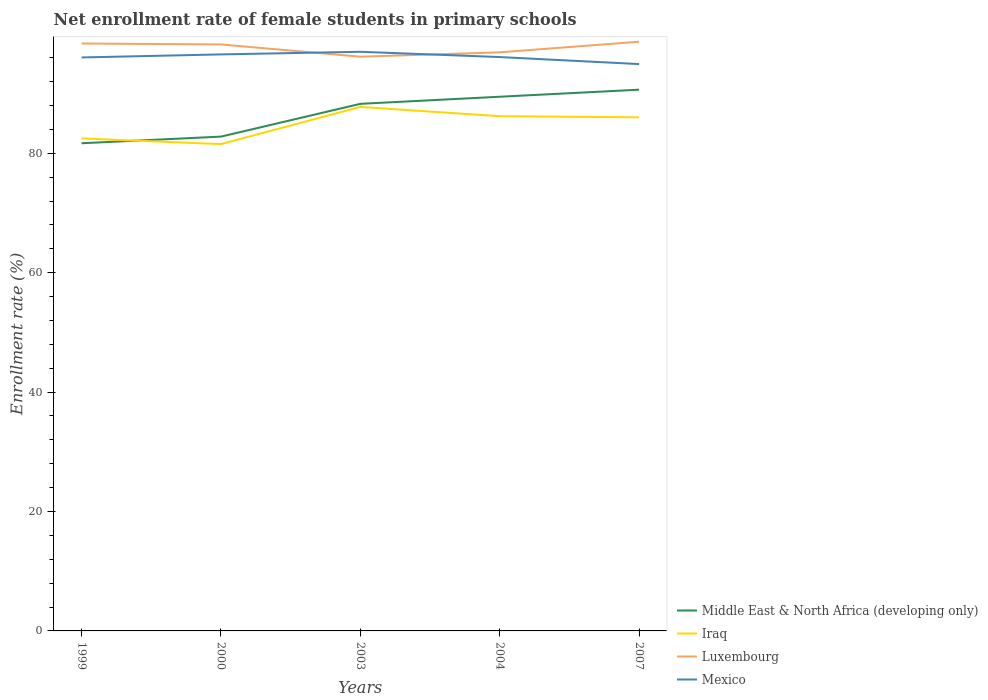How many different coloured lines are there?
Offer a terse response. 4. Does the line corresponding to Middle East & North Africa (developing only) intersect with the line corresponding to Mexico?
Give a very brief answer. No. Across all years, what is the maximum net enrollment rate of female students in primary schools in Luxembourg?
Provide a succinct answer. 96.18. What is the total net enrollment rate of female students in primary schools in Iraq in the graph?
Give a very brief answer. 0.95. What is the difference between the highest and the second highest net enrollment rate of female students in primary schools in Middle East & North Africa (developing only)?
Your answer should be very brief. 8.97. What is the difference between the highest and the lowest net enrollment rate of female students in primary schools in Middle East & North Africa (developing only)?
Ensure brevity in your answer.  3. How many lines are there?
Offer a terse response. 4. Are the values on the major ticks of Y-axis written in scientific E-notation?
Your answer should be compact. No. Does the graph contain grids?
Your answer should be very brief. No. Where does the legend appear in the graph?
Your response must be concise. Bottom right. How are the legend labels stacked?
Your answer should be compact. Vertical. What is the title of the graph?
Make the answer very short. Net enrollment rate of female students in primary schools. Does "Bermuda" appear as one of the legend labels in the graph?
Provide a succinct answer. No. What is the label or title of the X-axis?
Your answer should be compact. Years. What is the label or title of the Y-axis?
Your answer should be compact. Enrollment rate (%). What is the Enrollment rate (%) in Middle East & North Africa (developing only) in 1999?
Provide a succinct answer. 81.68. What is the Enrollment rate (%) in Iraq in 1999?
Offer a very short reply. 82.49. What is the Enrollment rate (%) of Luxembourg in 1999?
Your response must be concise. 98.39. What is the Enrollment rate (%) in Mexico in 1999?
Offer a very short reply. 96.05. What is the Enrollment rate (%) of Middle East & North Africa (developing only) in 2000?
Offer a terse response. 82.79. What is the Enrollment rate (%) in Iraq in 2000?
Provide a short and direct response. 81.54. What is the Enrollment rate (%) in Luxembourg in 2000?
Your answer should be very brief. 98.23. What is the Enrollment rate (%) of Mexico in 2000?
Provide a succinct answer. 96.56. What is the Enrollment rate (%) of Middle East & North Africa (developing only) in 2003?
Offer a terse response. 88.28. What is the Enrollment rate (%) in Iraq in 2003?
Make the answer very short. 87.76. What is the Enrollment rate (%) in Luxembourg in 2003?
Your answer should be very brief. 96.18. What is the Enrollment rate (%) in Mexico in 2003?
Offer a very short reply. 97. What is the Enrollment rate (%) in Middle East & North Africa (developing only) in 2004?
Your answer should be compact. 89.47. What is the Enrollment rate (%) in Iraq in 2004?
Give a very brief answer. 86.21. What is the Enrollment rate (%) of Luxembourg in 2004?
Ensure brevity in your answer.  96.9. What is the Enrollment rate (%) of Mexico in 2004?
Keep it short and to the point. 96.11. What is the Enrollment rate (%) in Middle East & North Africa (developing only) in 2007?
Your answer should be very brief. 90.65. What is the Enrollment rate (%) of Iraq in 2007?
Provide a succinct answer. 86.02. What is the Enrollment rate (%) in Luxembourg in 2007?
Your answer should be very brief. 98.69. What is the Enrollment rate (%) in Mexico in 2007?
Provide a short and direct response. 94.94. Across all years, what is the maximum Enrollment rate (%) of Middle East & North Africa (developing only)?
Provide a short and direct response. 90.65. Across all years, what is the maximum Enrollment rate (%) in Iraq?
Provide a succinct answer. 87.76. Across all years, what is the maximum Enrollment rate (%) in Luxembourg?
Offer a terse response. 98.69. Across all years, what is the maximum Enrollment rate (%) in Mexico?
Provide a short and direct response. 97. Across all years, what is the minimum Enrollment rate (%) of Middle East & North Africa (developing only)?
Your response must be concise. 81.68. Across all years, what is the minimum Enrollment rate (%) in Iraq?
Your answer should be very brief. 81.54. Across all years, what is the minimum Enrollment rate (%) of Luxembourg?
Provide a short and direct response. 96.18. Across all years, what is the minimum Enrollment rate (%) in Mexico?
Your answer should be very brief. 94.94. What is the total Enrollment rate (%) of Middle East & North Africa (developing only) in the graph?
Provide a short and direct response. 432.87. What is the total Enrollment rate (%) of Iraq in the graph?
Ensure brevity in your answer.  424.02. What is the total Enrollment rate (%) in Luxembourg in the graph?
Your response must be concise. 488.38. What is the total Enrollment rate (%) of Mexico in the graph?
Your response must be concise. 480.66. What is the difference between the Enrollment rate (%) of Middle East & North Africa (developing only) in 1999 and that in 2000?
Your answer should be compact. -1.11. What is the difference between the Enrollment rate (%) of Iraq in 1999 and that in 2000?
Give a very brief answer. 0.95. What is the difference between the Enrollment rate (%) in Luxembourg in 1999 and that in 2000?
Make the answer very short. 0.16. What is the difference between the Enrollment rate (%) in Mexico in 1999 and that in 2000?
Offer a very short reply. -0.51. What is the difference between the Enrollment rate (%) in Middle East & North Africa (developing only) in 1999 and that in 2003?
Give a very brief answer. -6.6. What is the difference between the Enrollment rate (%) in Iraq in 1999 and that in 2003?
Offer a very short reply. -5.28. What is the difference between the Enrollment rate (%) in Luxembourg in 1999 and that in 2003?
Offer a very short reply. 2.21. What is the difference between the Enrollment rate (%) in Mexico in 1999 and that in 2003?
Offer a terse response. -0.95. What is the difference between the Enrollment rate (%) in Middle East & North Africa (developing only) in 1999 and that in 2004?
Offer a very short reply. -7.79. What is the difference between the Enrollment rate (%) in Iraq in 1999 and that in 2004?
Ensure brevity in your answer.  -3.72. What is the difference between the Enrollment rate (%) of Luxembourg in 1999 and that in 2004?
Make the answer very short. 1.48. What is the difference between the Enrollment rate (%) of Mexico in 1999 and that in 2004?
Your response must be concise. -0.07. What is the difference between the Enrollment rate (%) in Middle East & North Africa (developing only) in 1999 and that in 2007?
Ensure brevity in your answer.  -8.97. What is the difference between the Enrollment rate (%) of Iraq in 1999 and that in 2007?
Offer a terse response. -3.53. What is the difference between the Enrollment rate (%) of Luxembourg in 1999 and that in 2007?
Give a very brief answer. -0.3. What is the difference between the Enrollment rate (%) of Mexico in 1999 and that in 2007?
Provide a succinct answer. 1.11. What is the difference between the Enrollment rate (%) in Middle East & North Africa (developing only) in 2000 and that in 2003?
Make the answer very short. -5.49. What is the difference between the Enrollment rate (%) in Iraq in 2000 and that in 2003?
Make the answer very short. -6.23. What is the difference between the Enrollment rate (%) in Luxembourg in 2000 and that in 2003?
Give a very brief answer. 2.05. What is the difference between the Enrollment rate (%) of Mexico in 2000 and that in 2003?
Your answer should be very brief. -0.44. What is the difference between the Enrollment rate (%) in Middle East & North Africa (developing only) in 2000 and that in 2004?
Offer a very short reply. -6.68. What is the difference between the Enrollment rate (%) in Iraq in 2000 and that in 2004?
Make the answer very short. -4.67. What is the difference between the Enrollment rate (%) of Luxembourg in 2000 and that in 2004?
Offer a terse response. 1.32. What is the difference between the Enrollment rate (%) in Mexico in 2000 and that in 2004?
Your response must be concise. 0.45. What is the difference between the Enrollment rate (%) in Middle East & North Africa (developing only) in 2000 and that in 2007?
Your answer should be very brief. -7.86. What is the difference between the Enrollment rate (%) of Iraq in 2000 and that in 2007?
Offer a very short reply. -4.48. What is the difference between the Enrollment rate (%) of Luxembourg in 2000 and that in 2007?
Provide a succinct answer. -0.46. What is the difference between the Enrollment rate (%) in Mexico in 2000 and that in 2007?
Your response must be concise. 1.62. What is the difference between the Enrollment rate (%) of Middle East & North Africa (developing only) in 2003 and that in 2004?
Offer a terse response. -1.19. What is the difference between the Enrollment rate (%) in Iraq in 2003 and that in 2004?
Your response must be concise. 1.55. What is the difference between the Enrollment rate (%) of Luxembourg in 2003 and that in 2004?
Keep it short and to the point. -0.73. What is the difference between the Enrollment rate (%) of Mexico in 2003 and that in 2004?
Your response must be concise. 0.88. What is the difference between the Enrollment rate (%) of Middle East & North Africa (developing only) in 2003 and that in 2007?
Provide a succinct answer. -2.37. What is the difference between the Enrollment rate (%) of Iraq in 2003 and that in 2007?
Keep it short and to the point. 1.74. What is the difference between the Enrollment rate (%) of Luxembourg in 2003 and that in 2007?
Make the answer very short. -2.51. What is the difference between the Enrollment rate (%) in Mexico in 2003 and that in 2007?
Make the answer very short. 2.06. What is the difference between the Enrollment rate (%) in Middle East & North Africa (developing only) in 2004 and that in 2007?
Make the answer very short. -1.18. What is the difference between the Enrollment rate (%) of Iraq in 2004 and that in 2007?
Offer a terse response. 0.19. What is the difference between the Enrollment rate (%) of Luxembourg in 2004 and that in 2007?
Your response must be concise. -1.78. What is the difference between the Enrollment rate (%) of Mexico in 2004 and that in 2007?
Provide a short and direct response. 1.18. What is the difference between the Enrollment rate (%) of Middle East & North Africa (developing only) in 1999 and the Enrollment rate (%) of Iraq in 2000?
Give a very brief answer. 0.14. What is the difference between the Enrollment rate (%) in Middle East & North Africa (developing only) in 1999 and the Enrollment rate (%) in Luxembourg in 2000?
Ensure brevity in your answer.  -16.55. What is the difference between the Enrollment rate (%) in Middle East & North Africa (developing only) in 1999 and the Enrollment rate (%) in Mexico in 2000?
Offer a very short reply. -14.88. What is the difference between the Enrollment rate (%) in Iraq in 1999 and the Enrollment rate (%) in Luxembourg in 2000?
Offer a terse response. -15.74. What is the difference between the Enrollment rate (%) in Iraq in 1999 and the Enrollment rate (%) in Mexico in 2000?
Make the answer very short. -14.07. What is the difference between the Enrollment rate (%) in Luxembourg in 1999 and the Enrollment rate (%) in Mexico in 2000?
Keep it short and to the point. 1.83. What is the difference between the Enrollment rate (%) in Middle East & North Africa (developing only) in 1999 and the Enrollment rate (%) in Iraq in 2003?
Provide a short and direct response. -6.09. What is the difference between the Enrollment rate (%) of Middle East & North Africa (developing only) in 1999 and the Enrollment rate (%) of Luxembourg in 2003?
Give a very brief answer. -14.5. What is the difference between the Enrollment rate (%) in Middle East & North Africa (developing only) in 1999 and the Enrollment rate (%) in Mexico in 2003?
Offer a terse response. -15.32. What is the difference between the Enrollment rate (%) in Iraq in 1999 and the Enrollment rate (%) in Luxembourg in 2003?
Provide a short and direct response. -13.69. What is the difference between the Enrollment rate (%) in Iraq in 1999 and the Enrollment rate (%) in Mexico in 2003?
Your response must be concise. -14.51. What is the difference between the Enrollment rate (%) of Luxembourg in 1999 and the Enrollment rate (%) of Mexico in 2003?
Your response must be concise. 1.39. What is the difference between the Enrollment rate (%) in Middle East & North Africa (developing only) in 1999 and the Enrollment rate (%) in Iraq in 2004?
Ensure brevity in your answer.  -4.53. What is the difference between the Enrollment rate (%) in Middle East & North Africa (developing only) in 1999 and the Enrollment rate (%) in Luxembourg in 2004?
Your answer should be compact. -15.23. What is the difference between the Enrollment rate (%) of Middle East & North Africa (developing only) in 1999 and the Enrollment rate (%) of Mexico in 2004?
Offer a very short reply. -14.44. What is the difference between the Enrollment rate (%) in Iraq in 1999 and the Enrollment rate (%) in Luxembourg in 2004?
Keep it short and to the point. -14.42. What is the difference between the Enrollment rate (%) of Iraq in 1999 and the Enrollment rate (%) of Mexico in 2004?
Provide a short and direct response. -13.63. What is the difference between the Enrollment rate (%) in Luxembourg in 1999 and the Enrollment rate (%) in Mexico in 2004?
Provide a succinct answer. 2.27. What is the difference between the Enrollment rate (%) of Middle East & North Africa (developing only) in 1999 and the Enrollment rate (%) of Iraq in 2007?
Keep it short and to the point. -4.34. What is the difference between the Enrollment rate (%) in Middle East & North Africa (developing only) in 1999 and the Enrollment rate (%) in Luxembourg in 2007?
Offer a terse response. -17.01. What is the difference between the Enrollment rate (%) in Middle East & North Africa (developing only) in 1999 and the Enrollment rate (%) in Mexico in 2007?
Ensure brevity in your answer.  -13.26. What is the difference between the Enrollment rate (%) in Iraq in 1999 and the Enrollment rate (%) in Luxembourg in 2007?
Ensure brevity in your answer.  -16.2. What is the difference between the Enrollment rate (%) of Iraq in 1999 and the Enrollment rate (%) of Mexico in 2007?
Give a very brief answer. -12.45. What is the difference between the Enrollment rate (%) of Luxembourg in 1999 and the Enrollment rate (%) of Mexico in 2007?
Offer a very short reply. 3.45. What is the difference between the Enrollment rate (%) in Middle East & North Africa (developing only) in 2000 and the Enrollment rate (%) in Iraq in 2003?
Keep it short and to the point. -4.97. What is the difference between the Enrollment rate (%) in Middle East & North Africa (developing only) in 2000 and the Enrollment rate (%) in Luxembourg in 2003?
Your response must be concise. -13.39. What is the difference between the Enrollment rate (%) of Middle East & North Africa (developing only) in 2000 and the Enrollment rate (%) of Mexico in 2003?
Keep it short and to the point. -14.21. What is the difference between the Enrollment rate (%) in Iraq in 2000 and the Enrollment rate (%) in Luxembourg in 2003?
Your response must be concise. -14.64. What is the difference between the Enrollment rate (%) in Iraq in 2000 and the Enrollment rate (%) in Mexico in 2003?
Offer a very short reply. -15.46. What is the difference between the Enrollment rate (%) of Luxembourg in 2000 and the Enrollment rate (%) of Mexico in 2003?
Offer a terse response. 1.23. What is the difference between the Enrollment rate (%) in Middle East & North Africa (developing only) in 2000 and the Enrollment rate (%) in Iraq in 2004?
Offer a terse response. -3.42. What is the difference between the Enrollment rate (%) in Middle East & North Africa (developing only) in 2000 and the Enrollment rate (%) in Luxembourg in 2004?
Your answer should be very brief. -14.12. What is the difference between the Enrollment rate (%) of Middle East & North Africa (developing only) in 2000 and the Enrollment rate (%) of Mexico in 2004?
Offer a terse response. -13.32. What is the difference between the Enrollment rate (%) of Iraq in 2000 and the Enrollment rate (%) of Luxembourg in 2004?
Make the answer very short. -15.37. What is the difference between the Enrollment rate (%) of Iraq in 2000 and the Enrollment rate (%) of Mexico in 2004?
Keep it short and to the point. -14.58. What is the difference between the Enrollment rate (%) of Luxembourg in 2000 and the Enrollment rate (%) of Mexico in 2004?
Your answer should be compact. 2.11. What is the difference between the Enrollment rate (%) in Middle East & North Africa (developing only) in 2000 and the Enrollment rate (%) in Iraq in 2007?
Give a very brief answer. -3.23. What is the difference between the Enrollment rate (%) of Middle East & North Africa (developing only) in 2000 and the Enrollment rate (%) of Luxembourg in 2007?
Give a very brief answer. -15.9. What is the difference between the Enrollment rate (%) of Middle East & North Africa (developing only) in 2000 and the Enrollment rate (%) of Mexico in 2007?
Provide a short and direct response. -12.15. What is the difference between the Enrollment rate (%) of Iraq in 2000 and the Enrollment rate (%) of Luxembourg in 2007?
Give a very brief answer. -17.15. What is the difference between the Enrollment rate (%) in Iraq in 2000 and the Enrollment rate (%) in Mexico in 2007?
Offer a very short reply. -13.4. What is the difference between the Enrollment rate (%) in Luxembourg in 2000 and the Enrollment rate (%) in Mexico in 2007?
Provide a succinct answer. 3.29. What is the difference between the Enrollment rate (%) in Middle East & North Africa (developing only) in 2003 and the Enrollment rate (%) in Iraq in 2004?
Keep it short and to the point. 2.07. What is the difference between the Enrollment rate (%) of Middle East & North Africa (developing only) in 2003 and the Enrollment rate (%) of Luxembourg in 2004?
Offer a terse response. -8.62. What is the difference between the Enrollment rate (%) in Middle East & North Africa (developing only) in 2003 and the Enrollment rate (%) in Mexico in 2004?
Your response must be concise. -7.83. What is the difference between the Enrollment rate (%) in Iraq in 2003 and the Enrollment rate (%) in Luxembourg in 2004?
Provide a short and direct response. -9.14. What is the difference between the Enrollment rate (%) in Iraq in 2003 and the Enrollment rate (%) in Mexico in 2004?
Make the answer very short. -8.35. What is the difference between the Enrollment rate (%) of Luxembourg in 2003 and the Enrollment rate (%) of Mexico in 2004?
Your answer should be compact. 0.06. What is the difference between the Enrollment rate (%) of Middle East & North Africa (developing only) in 2003 and the Enrollment rate (%) of Iraq in 2007?
Make the answer very short. 2.26. What is the difference between the Enrollment rate (%) in Middle East & North Africa (developing only) in 2003 and the Enrollment rate (%) in Luxembourg in 2007?
Your answer should be very brief. -10.41. What is the difference between the Enrollment rate (%) in Middle East & North Africa (developing only) in 2003 and the Enrollment rate (%) in Mexico in 2007?
Ensure brevity in your answer.  -6.66. What is the difference between the Enrollment rate (%) of Iraq in 2003 and the Enrollment rate (%) of Luxembourg in 2007?
Make the answer very short. -10.92. What is the difference between the Enrollment rate (%) of Iraq in 2003 and the Enrollment rate (%) of Mexico in 2007?
Make the answer very short. -7.17. What is the difference between the Enrollment rate (%) in Luxembourg in 2003 and the Enrollment rate (%) in Mexico in 2007?
Keep it short and to the point. 1.24. What is the difference between the Enrollment rate (%) in Middle East & North Africa (developing only) in 2004 and the Enrollment rate (%) in Iraq in 2007?
Your answer should be very brief. 3.45. What is the difference between the Enrollment rate (%) in Middle East & North Africa (developing only) in 2004 and the Enrollment rate (%) in Luxembourg in 2007?
Offer a very short reply. -9.22. What is the difference between the Enrollment rate (%) of Middle East & North Africa (developing only) in 2004 and the Enrollment rate (%) of Mexico in 2007?
Offer a very short reply. -5.47. What is the difference between the Enrollment rate (%) of Iraq in 2004 and the Enrollment rate (%) of Luxembourg in 2007?
Offer a very short reply. -12.48. What is the difference between the Enrollment rate (%) of Iraq in 2004 and the Enrollment rate (%) of Mexico in 2007?
Offer a terse response. -8.73. What is the difference between the Enrollment rate (%) in Luxembourg in 2004 and the Enrollment rate (%) in Mexico in 2007?
Provide a short and direct response. 1.97. What is the average Enrollment rate (%) in Middle East & North Africa (developing only) per year?
Keep it short and to the point. 86.57. What is the average Enrollment rate (%) in Iraq per year?
Keep it short and to the point. 84.8. What is the average Enrollment rate (%) of Luxembourg per year?
Your response must be concise. 97.68. What is the average Enrollment rate (%) in Mexico per year?
Your response must be concise. 96.13. In the year 1999, what is the difference between the Enrollment rate (%) of Middle East & North Africa (developing only) and Enrollment rate (%) of Iraq?
Provide a short and direct response. -0.81. In the year 1999, what is the difference between the Enrollment rate (%) in Middle East & North Africa (developing only) and Enrollment rate (%) in Luxembourg?
Your response must be concise. -16.71. In the year 1999, what is the difference between the Enrollment rate (%) in Middle East & North Africa (developing only) and Enrollment rate (%) in Mexico?
Give a very brief answer. -14.37. In the year 1999, what is the difference between the Enrollment rate (%) in Iraq and Enrollment rate (%) in Luxembourg?
Offer a very short reply. -15.9. In the year 1999, what is the difference between the Enrollment rate (%) of Iraq and Enrollment rate (%) of Mexico?
Make the answer very short. -13.56. In the year 1999, what is the difference between the Enrollment rate (%) in Luxembourg and Enrollment rate (%) in Mexico?
Make the answer very short. 2.34. In the year 2000, what is the difference between the Enrollment rate (%) of Middle East & North Africa (developing only) and Enrollment rate (%) of Iraq?
Make the answer very short. 1.25. In the year 2000, what is the difference between the Enrollment rate (%) of Middle East & North Africa (developing only) and Enrollment rate (%) of Luxembourg?
Give a very brief answer. -15.44. In the year 2000, what is the difference between the Enrollment rate (%) of Middle East & North Africa (developing only) and Enrollment rate (%) of Mexico?
Make the answer very short. -13.77. In the year 2000, what is the difference between the Enrollment rate (%) of Iraq and Enrollment rate (%) of Luxembourg?
Provide a succinct answer. -16.69. In the year 2000, what is the difference between the Enrollment rate (%) in Iraq and Enrollment rate (%) in Mexico?
Your response must be concise. -15.02. In the year 2000, what is the difference between the Enrollment rate (%) of Luxembourg and Enrollment rate (%) of Mexico?
Offer a terse response. 1.67. In the year 2003, what is the difference between the Enrollment rate (%) of Middle East & North Africa (developing only) and Enrollment rate (%) of Iraq?
Your response must be concise. 0.52. In the year 2003, what is the difference between the Enrollment rate (%) in Middle East & North Africa (developing only) and Enrollment rate (%) in Luxembourg?
Your answer should be compact. -7.9. In the year 2003, what is the difference between the Enrollment rate (%) in Middle East & North Africa (developing only) and Enrollment rate (%) in Mexico?
Your answer should be very brief. -8.72. In the year 2003, what is the difference between the Enrollment rate (%) of Iraq and Enrollment rate (%) of Luxembourg?
Provide a short and direct response. -8.41. In the year 2003, what is the difference between the Enrollment rate (%) in Iraq and Enrollment rate (%) in Mexico?
Your answer should be compact. -9.23. In the year 2003, what is the difference between the Enrollment rate (%) of Luxembourg and Enrollment rate (%) of Mexico?
Make the answer very short. -0.82. In the year 2004, what is the difference between the Enrollment rate (%) in Middle East & North Africa (developing only) and Enrollment rate (%) in Iraq?
Your answer should be compact. 3.26. In the year 2004, what is the difference between the Enrollment rate (%) in Middle East & North Africa (developing only) and Enrollment rate (%) in Luxembourg?
Make the answer very short. -7.44. In the year 2004, what is the difference between the Enrollment rate (%) in Middle East & North Africa (developing only) and Enrollment rate (%) in Mexico?
Ensure brevity in your answer.  -6.65. In the year 2004, what is the difference between the Enrollment rate (%) in Iraq and Enrollment rate (%) in Luxembourg?
Your response must be concise. -10.7. In the year 2004, what is the difference between the Enrollment rate (%) in Iraq and Enrollment rate (%) in Mexico?
Your answer should be very brief. -9.9. In the year 2004, what is the difference between the Enrollment rate (%) in Luxembourg and Enrollment rate (%) in Mexico?
Your answer should be compact. 0.79. In the year 2007, what is the difference between the Enrollment rate (%) of Middle East & North Africa (developing only) and Enrollment rate (%) of Iraq?
Offer a terse response. 4.63. In the year 2007, what is the difference between the Enrollment rate (%) of Middle East & North Africa (developing only) and Enrollment rate (%) of Luxembourg?
Your answer should be very brief. -8.04. In the year 2007, what is the difference between the Enrollment rate (%) of Middle East & North Africa (developing only) and Enrollment rate (%) of Mexico?
Your answer should be compact. -4.29. In the year 2007, what is the difference between the Enrollment rate (%) of Iraq and Enrollment rate (%) of Luxembourg?
Keep it short and to the point. -12.67. In the year 2007, what is the difference between the Enrollment rate (%) in Iraq and Enrollment rate (%) in Mexico?
Provide a succinct answer. -8.92. In the year 2007, what is the difference between the Enrollment rate (%) in Luxembourg and Enrollment rate (%) in Mexico?
Provide a short and direct response. 3.75. What is the ratio of the Enrollment rate (%) of Middle East & North Africa (developing only) in 1999 to that in 2000?
Provide a succinct answer. 0.99. What is the ratio of the Enrollment rate (%) in Iraq in 1999 to that in 2000?
Give a very brief answer. 1.01. What is the ratio of the Enrollment rate (%) in Mexico in 1999 to that in 2000?
Keep it short and to the point. 0.99. What is the ratio of the Enrollment rate (%) of Middle East & North Africa (developing only) in 1999 to that in 2003?
Keep it short and to the point. 0.93. What is the ratio of the Enrollment rate (%) of Iraq in 1999 to that in 2003?
Keep it short and to the point. 0.94. What is the ratio of the Enrollment rate (%) of Luxembourg in 1999 to that in 2003?
Give a very brief answer. 1.02. What is the ratio of the Enrollment rate (%) in Mexico in 1999 to that in 2003?
Keep it short and to the point. 0.99. What is the ratio of the Enrollment rate (%) of Middle East & North Africa (developing only) in 1999 to that in 2004?
Offer a very short reply. 0.91. What is the ratio of the Enrollment rate (%) of Iraq in 1999 to that in 2004?
Give a very brief answer. 0.96. What is the ratio of the Enrollment rate (%) of Luxembourg in 1999 to that in 2004?
Make the answer very short. 1.02. What is the ratio of the Enrollment rate (%) in Mexico in 1999 to that in 2004?
Your answer should be very brief. 1. What is the ratio of the Enrollment rate (%) in Middle East & North Africa (developing only) in 1999 to that in 2007?
Offer a terse response. 0.9. What is the ratio of the Enrollment rate (%) in Iraq in 1999 to that in 2007?
Offer a terse response. 0.96. What is the ratio of the Enrollment rate (%) of Luxembourg in 1999 to that in 2007?
Your answer should be compact. 1. What is the ratio of the Enrollment rate (%) in Mexico in 1999 to that in 2007?
Offer a very short reply. 1.01. What is the ratio of the Enrollment rate (%) in Middle East & North Africa (developing only) in 2000 to that in 2003?
Give a very brief answer. 0.94. What is the ratio of the Enrollment rate (%) in Iraq in 2000 to that in 2003?
Offer a very short reply. 0.93. What is the ratio of the Enrollment rate (%) in Luxembourg in 2000 to that in 2003?
Keep it short and to the point. 1.02. What is the ratio of the Enrollment rate (%) of Mexico in 2000 to that in 2003?
Offer a terse response. 1. What is the ratio of the Enrollment rate (%) in Middle East & North Africa (developing only) in 2000 to that in 2004?
Offer a terse response. 0.93. What is the ratio of the Enrollment rate (%) in Iraq in 2000 to that in 2004?
Ensure brevity in your answer.  0.95. What is the ratio of the Enrollment rate (%) of Luxembourg in 2000 to that in 2004?
Offer a very short reply. 1.01. What is the ratio of the Enrollment rate (%) in Mexico in 2000 to that in 2004?
Your response must be concise. 1. What is the ratio of the Enrollment rate (%) in Middle East & North Africa (developing only) in 2000 to that in 2007?
Offer a terse response. 0.91. What is the ratio of the Enrollment rate (%) in Iraq in 2000 to that in 2007?
Give a very brief answer. 0.95. What is the ratio of the Enrollment rate (%) of Mexico in 2000 to that in 2007?
Ensure brevity in your answer.  1.02. What is the ratio of the Enrollment rate (%) in Middle East & North Africa (developing only) in 2003 to that in 2004?
Make the answer very short. 0.99. What is the ratio of the Enrollment rate (%) of Mexico in 2003 to that in 2004?
Provide a succinct answer. 1.01. What is the ratio of the Enrollment rate (%) in Middle East & North Africa (developing only) in 2003 to that in 2007?
Provide a succinct answer. 0.97. What is the ratio of the Enrollment rate (%) of Iraq in 2003 to that in 2007?
Keep it short and to the point. 1.02. What is the ratio of the Enrollment rate (%) in Luxembourg in 2003 to that in 2007?
Provide a succinct answer. 0.97. What is the ratio of the Enrollment rate (%) in Mexico in 2003 to that in 2007?
Offer a very short reply. 1.02. What is the ratio of the Enrollment rate (%) of Middle East & North Africa (developing only) in 2004 to that in 2007?
Give a very brief answer. 0.99. What is the ratio of the Enrollment rate (%) of Luxembourg in 2004 to that in 2007?
Your answer should be very brief. 0.98. What is the ratio of the Enrollment rate (%) in Mexico in 2004 to that in 2007?
Offer a terse response. 1.01. What is the difference between the highest and the second highest Enrollment rate (%) in Middle East & North Africa (developing only)?
Your answer should be compact. 1.18. What is the difference between the highest and the second highest Enrollment rate (%) in Iraq?
Offer a very short reply. 1.55. What is the difference between the highest and the second highest Enrollment rate (%) of Luxembourg?
Keep it short and to the point. 0.3. What is the difference between the highest and the second highest Enrollment rate (%) in Mexico?
Your answer should be very brief. 0.44. What is the difference between the highest and the lowest Enrollment rate (%) in Middle East & North Africa (developing only)?
Your answer should be very brief. 8.97. What is the difference between the highest and the lowest Enrollment rate (%) of Iraq?
Ensure brevity in your answer.  6.23. What is the difference between the highest and the lowest Enrollment rate (%) of Luxembourg?
Your answer should be compact. 2.51. What is the difference between the highest and the lowest Enrollment rate (%) of Mexico?
Your response must be concise. 2.06. 